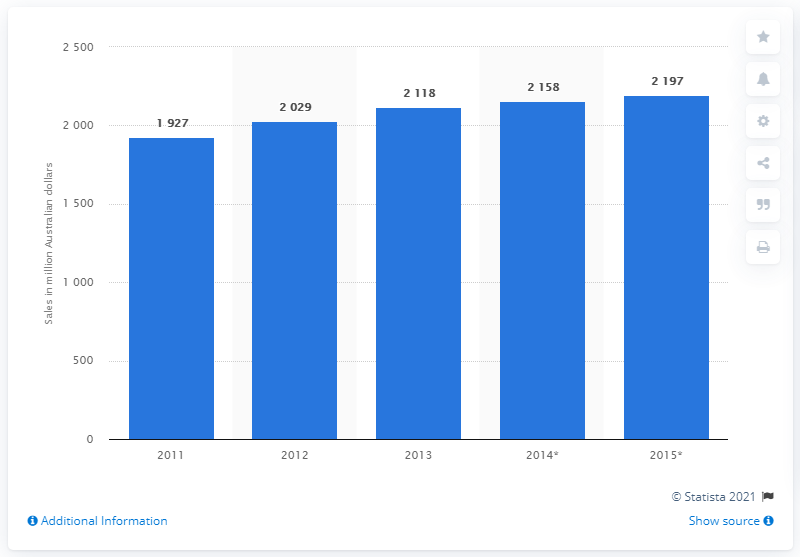Draw attention to some important aspects in this diagram. In 2015, the predicted sales of over-the-counter medicines in Australia were 2,197. 